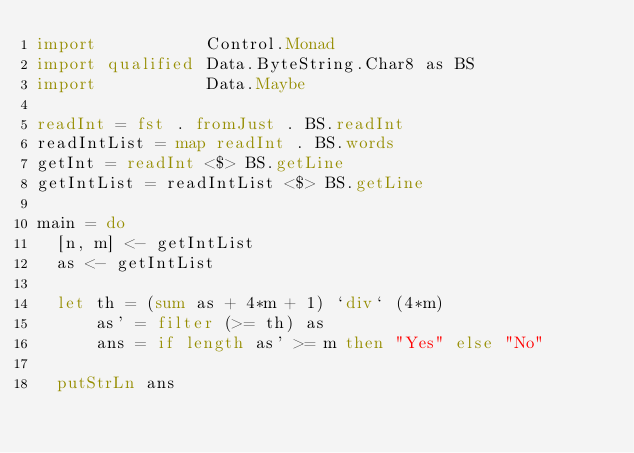Convert code to text. <code><loc_0><loc_0><loc_500><loc_500><_Haskell_>import           Control.Monad
import qualified Data.ByteString.Char8 as BS
import           Data.Maybe

readInt = fst . fromJust . BS.readInt
readIntList = map readInt . BS.words
getInt = readInt <$> BS.getLine
getIntList = readIntList <$> BS.getLine

main = do
  [n, m] <- getIntList
  as <- getIntList

  let th = (sum as + 4*m + 1) `div` (4*m)
      as' = filter (>= th) as
      ans = if length as' >= m then "Yes" else "No"

  putStrLn ans</code> 